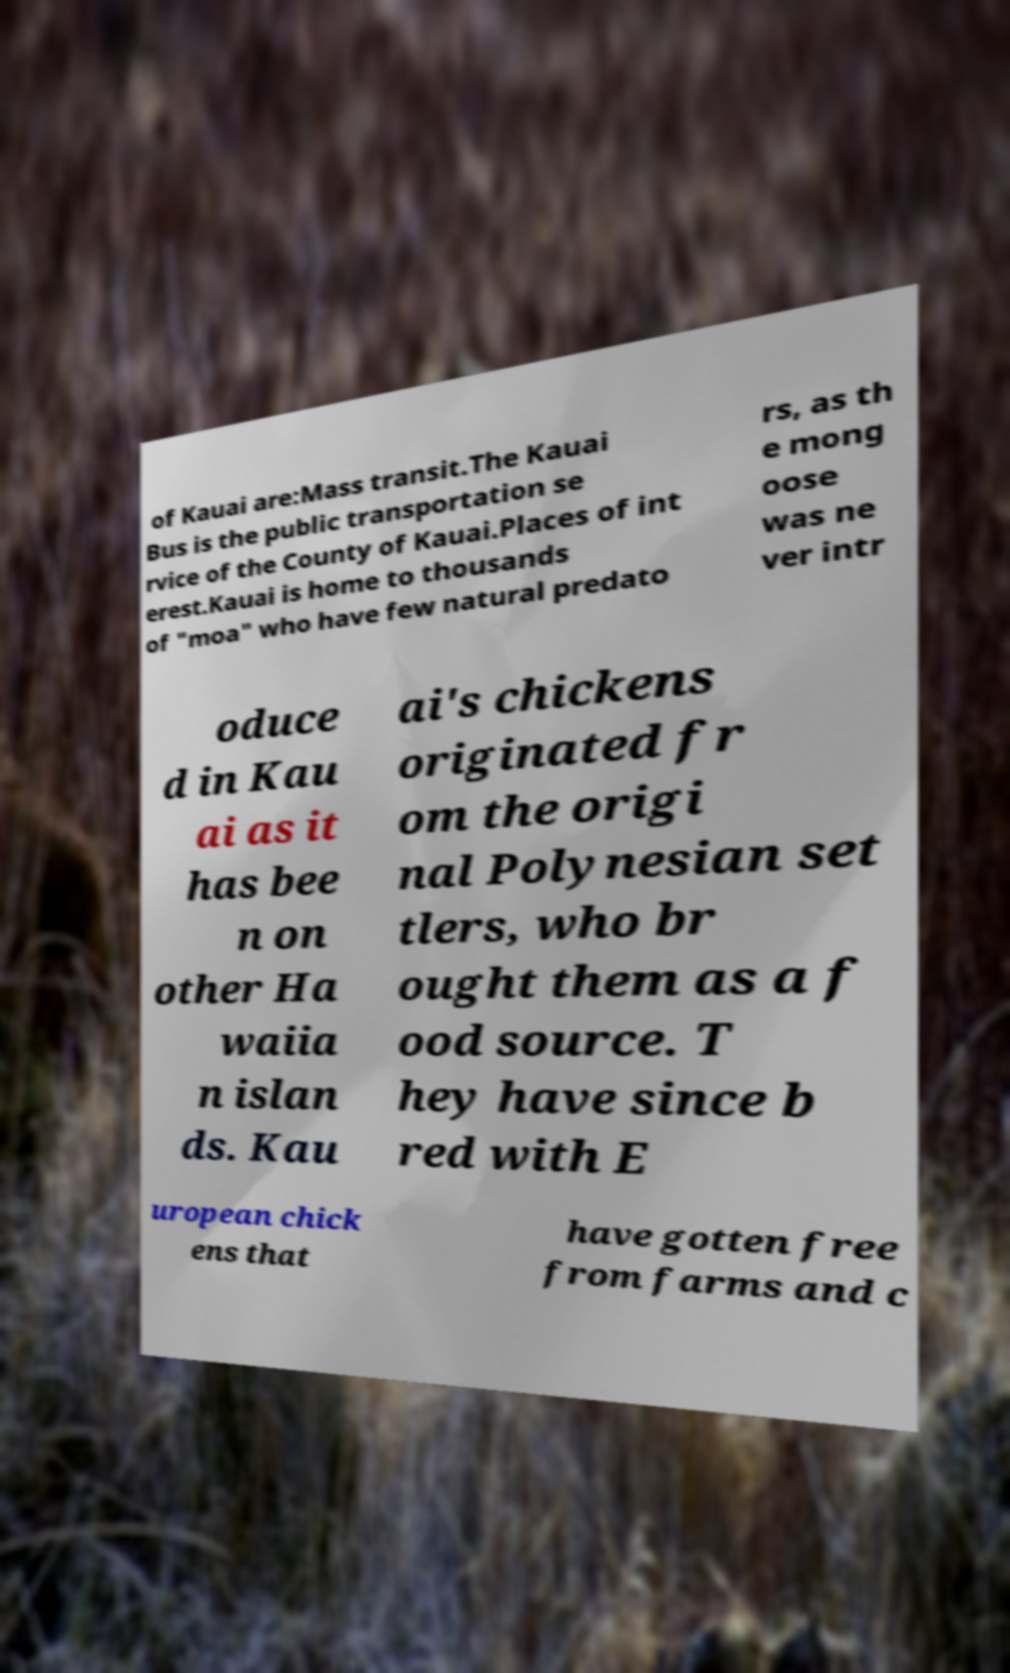Please read and relay the text visible in this image. What does it say? of Kauai are:Mass transit.The Kauai Bus is the public transportation se rvice of the County of Kauai.Places of int erest.Kauai is home to thousands of "moa" who have few natural predato rs, as th e mong oose was ne ver intr oduce d in Kau ai as it has bee n on other Ha waiia n islan ds. Kau ai's chickens originated fr om the origi nal Polynesian set tlers, who br ought them as a f ood source. T hey have since b red with E uropean chick ens that have gotten free from farms and c 